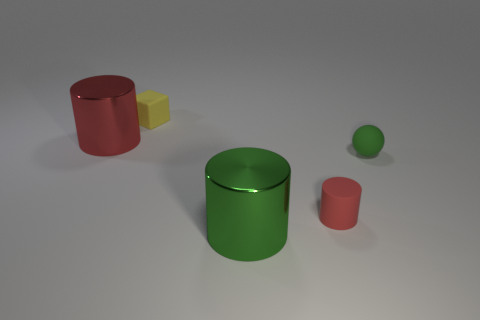Is there a big cylinder that is to the right of the big metal cylinder to the left of the green shiny cylinder that is to the left of the small red rubber object?
Provide a short and direct response. Yes. What is the material of the large thing that is left of the large green cylinder?
Your answer should be very brief. Metal. Is the shape of the large green metallic thing the same as the small rubber object in front of the rubber ball?
Your answer should be very brief. Yes. Are there an equal number of tiny blocks that are in front of the matte cylinder and small yellow matte things to the left of the big green shiny cylinder?
Make the answer very short. No. What number of other things are there of the same material as the large green object
Your answer should be compact. 1. What number of matte objects are either spheres or small red cylinders?
Offer a very short reply. 2. There is a metallic object right of the yellow rubber block; is it the same shape as the tiny green thing?
Offer a very short reply. No. Are there more small yellow things that are behind the small green matte object than big red balls?
Your answer should be compact. Yes. How many tiny things are both in front of the tiny yellow object and behind the rubber cylinder?
Offer a terse response. 1. What color is the cylinder to the right of the large metal cylinder that is in front of the tiny red rubber object?
Your answer should be compact. Red. 